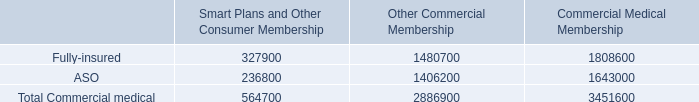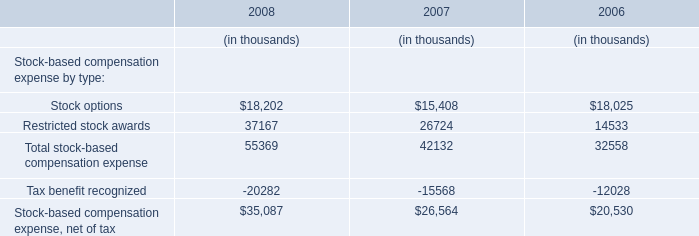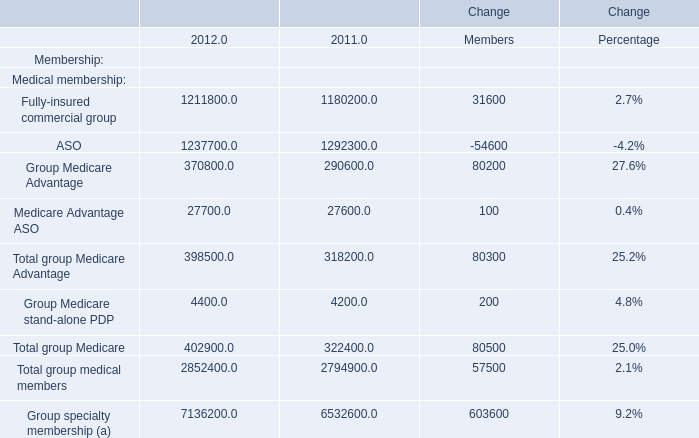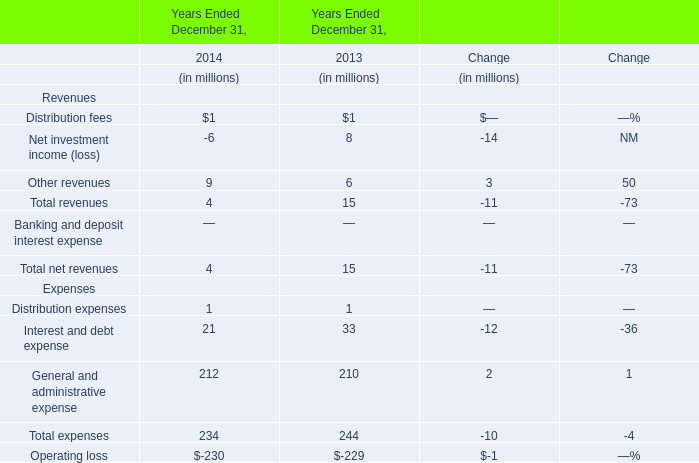What is the growing rate of General and administrative expense in the years with the most Other revenues? 
Computations: ((212 - 210) / 210)
Answer: 0.00952. 